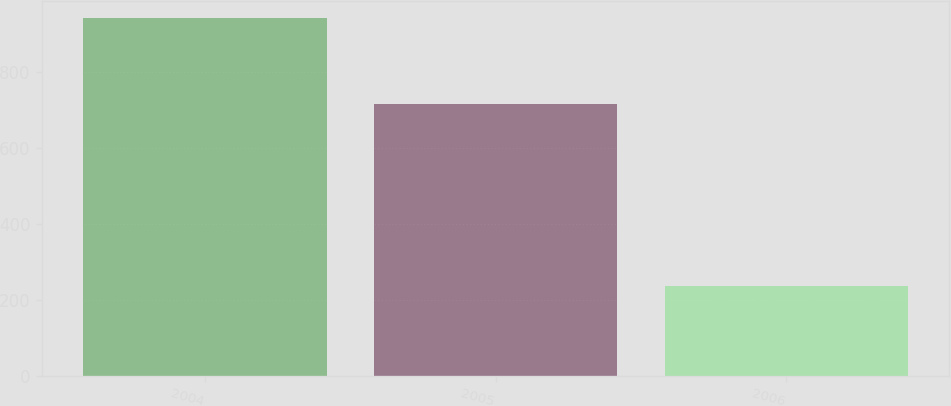Convert chart. <chart><loc_0><loc_0><loc_500><loc_500><bar_chart><fcel>2004<fcel>2005<fcel>2006<nl><fcel>941<fcel>716<fcel>235<nl></chart> 